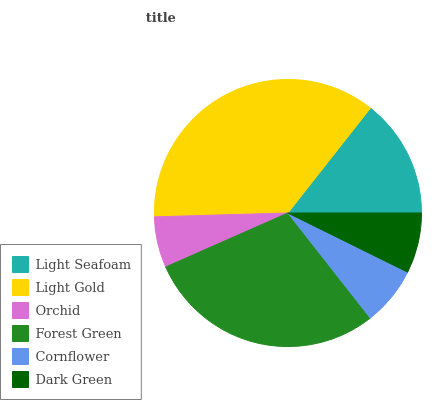Is Orchid the minimum?
Answer yes or no. Yes. Is Light Gold the maximum?
Answer yes or no. Yes. Is Light Gold the minimum?
Answer yes or no. No. Is Orchid the maximum?
Answer yes or no. No. Is Light Gold greater than Orchid?
Answer yes or no. Yes. Is Orchid less than Light Gold?
Answer yes or no. Yes. Is Orchid greater than Light Gold?
Answer yes or no. No. Is Light Gold less than Orchid?
Answer yes or no. No. Is Light Seafoam the high median?
Answer yes or no. Yes. Is Dark Green the low median?
Answer yes or no. Yes. Is Forest Green the high median?
Answer yes or no. No. Is Light Seafoam the low median?
Answer yes or no. No. 